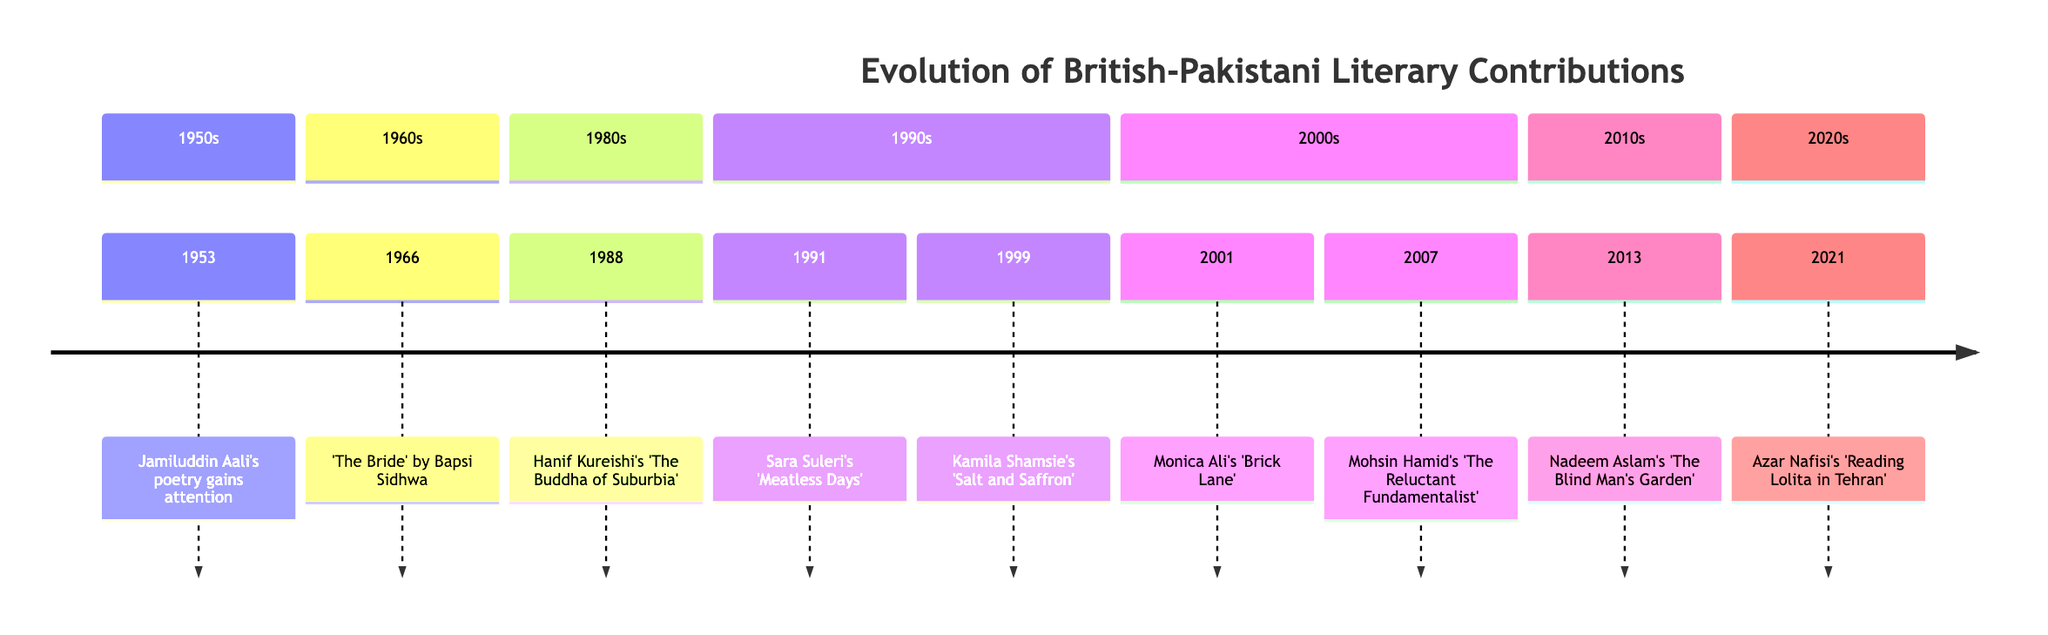What year did Bapsi Sidhwa publish 'The Bride'? According to the timeline, 'The Bride' by Bapsi Sidhwa was published in 1966.
Answer: 1966 Who wrote 'The Reluctant Fundamentalist'? The timeline indicates that Mohsin Hamid is the author of 'The Reluctant Fundamentalist'.
Answer: Mohsin Hamid How many works are listed in the 1990s? Reviewing the timeline, there are two works listed in the 1990s: Sara Suleri's 'Meatless Days' (1991) and Kamila Shamsie's 'Salt and Saffron' (1999).
Answer: 2 What is the cultural theme explored in Hanif Kureishi's 'The Buddha of Suburbia'? The timeline mentions that the work delves into multiculturalism in Britain.
Answer: Multiculturalism Which author contributed to the timeline in the year 2001? The timeline shows that Monica Ali published her work in 2001, which was 'Brick Lane'.
Answer: Monica Ali What event reflects the influence of literature in oppressive environments? The timeline indicates that Azar Nafisi's 'Reading Lolita in Tehran' showcases the power of literature in oppressive conditions, even though she is Iranian-American.
Answer: Azar Nafisi What decade did Kamila Shamsie release 'Salt and Saffron'? The timeline states that Kamila Shamsie released 'Salt and Saffron' in the 1990s.
Answer: 1990s Which work addresses the immigrant experience in Britain? The timeline specifies that 'Brick Lane' by Monica Ali illustrates the immigrant experience in Britain.
Answer: Brick Lane How does 'Meatless Days' relate to multicultural identity? Since 'Meatless Days' is recognized for its exploration of multicultural upbringing and identity, it relates directly to understanding various identities.
Answer: Multicultural identity 